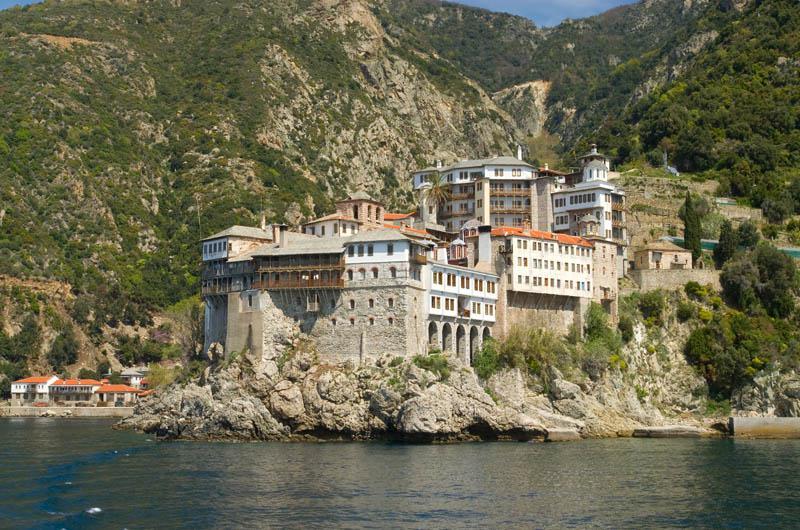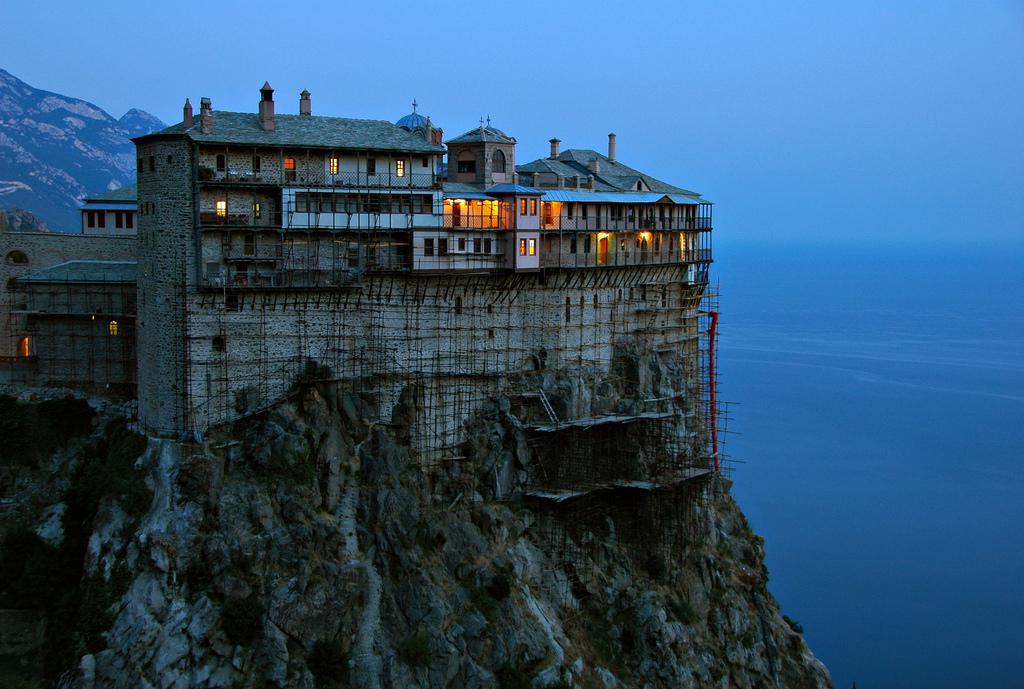The first image is the image on the left, the second image is the image on the right. Assess this claim about the two images: "In at least one image there is a large home on top of a rock mountain with one mountain behind it to the left.". Correct or not? Answer yes or no. Yes. The first image is the image on the left, the second image is the image on the right. Analyze the images presented: Is the assertion "The ocean is visible behind the buildings and cliffside in the left image, but it is not visible in the right image." valid? Answer yes or no. No. 